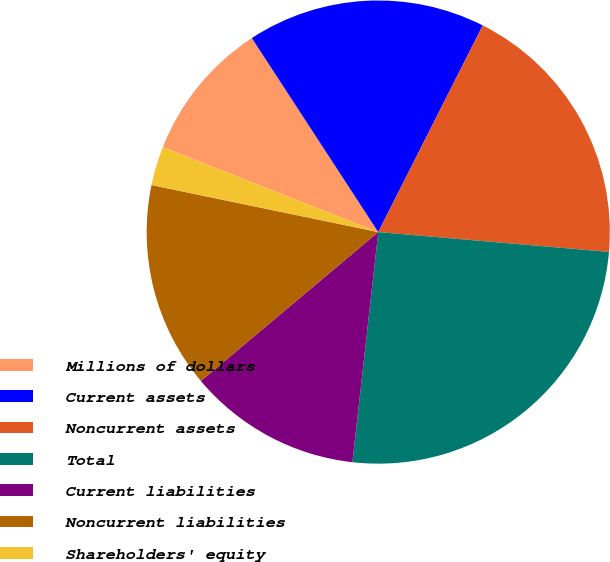Convert chart. <chart><loc_0><loc_0><loc_500><loc_500><pie_chart><fcel>Millions of dollars<fcel>Current assets<fcel>Noncurrent assets<fcel>Total<fcel>Current liabilities<fcel>Noncurrent liabilities<fcel>Shareholders' equity<nl><fcel>9.83%<fcel>16.64%<fcel>18.91%<fcel>25.41%<fcel>12.1%<fcel>14.37%<fcel>2.72%<nl></chart> 